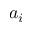<formula> <loc_0><loc_0><loc_500><loc_500>a _ { i }</formula> 